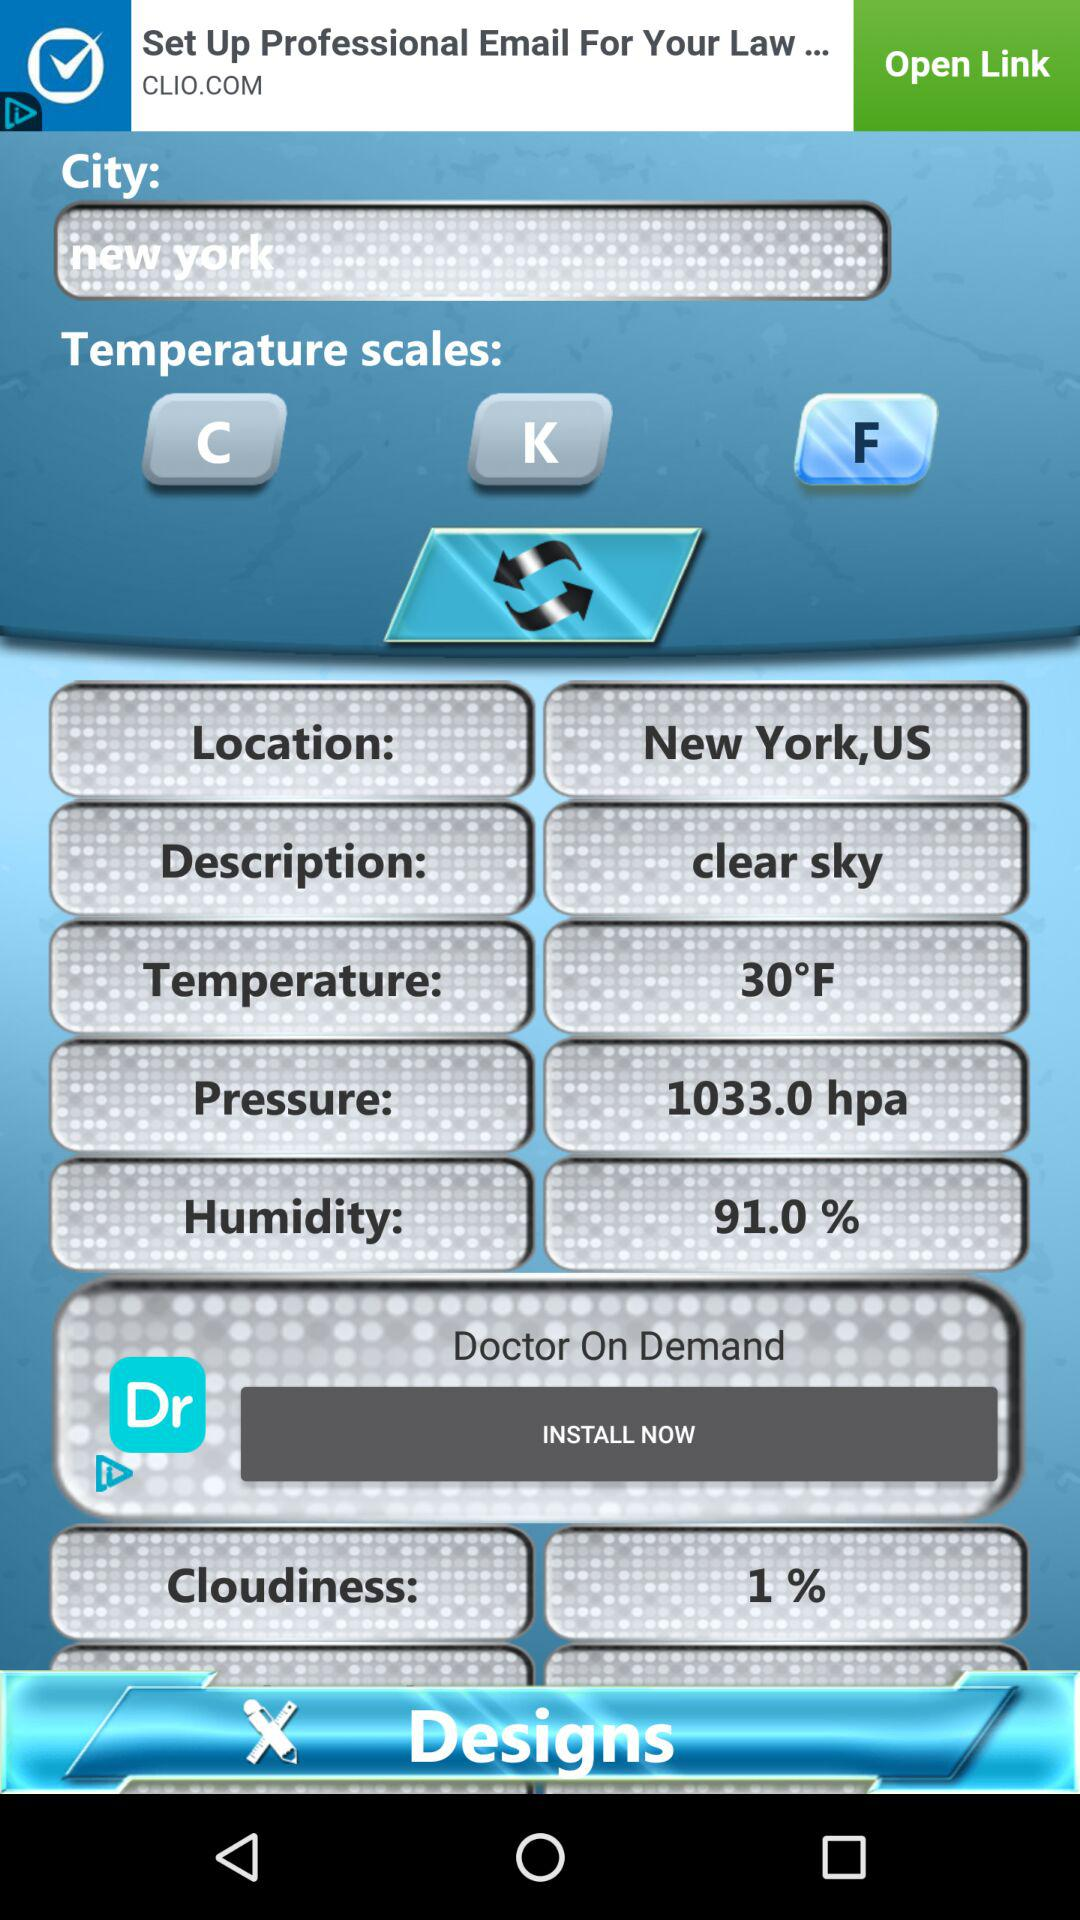What is the percentage of cloudiness in New York? The percentage is 1. 